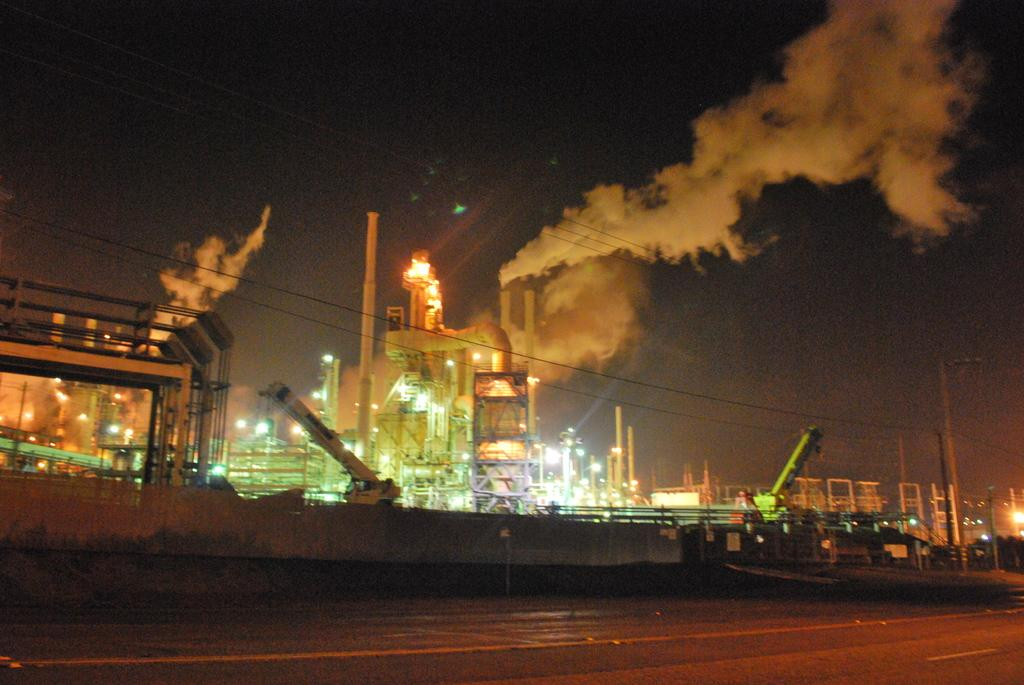What is the main feature of the image? There is a road in the image. What can be seen in the background of the image? In the background, there are cranes, factories, poles, and the sky. What type of structures are present in the background? The structures in the background are factories. What else can be seen in the background besides the factories? There are also cranes and poles visible in the background. How many cherries are hanging from the poles in the image? There are no cherries present in the image; the poles are in the background of the image, but they do not have any cherries hanging from them. Can you see a ray of light shining through the sky in the image? The presence of a ray of light is not mentioned in the provided facts, so we cannot determine if it is present in the image. 